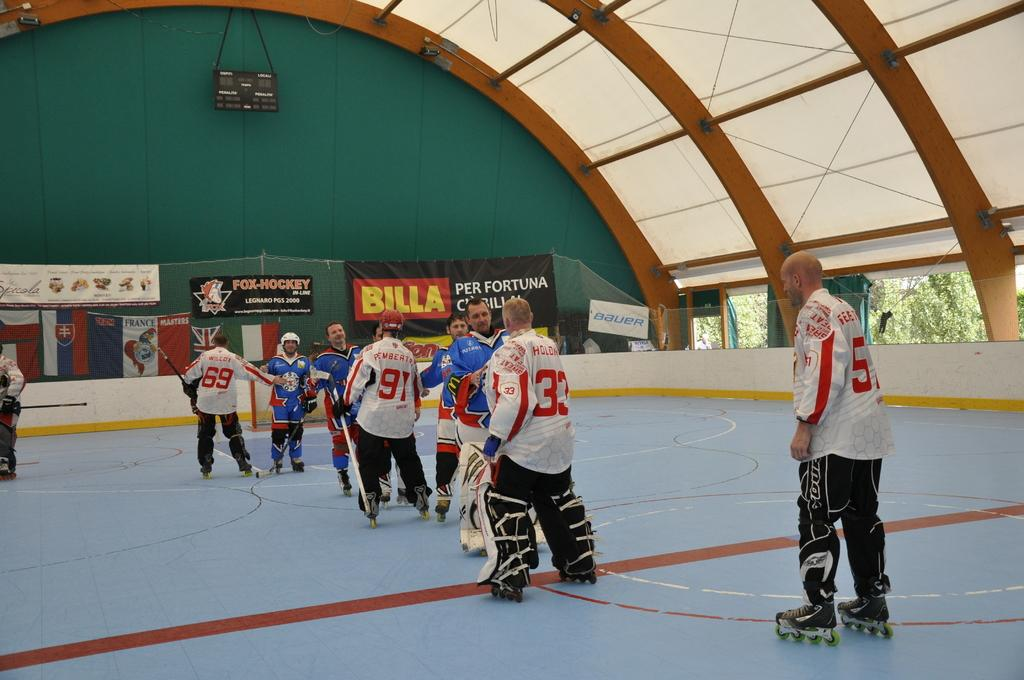<image>
Write a terse but informative summary of the picture. A Billa banner is hanging on the wall near people playing roller hockey. 